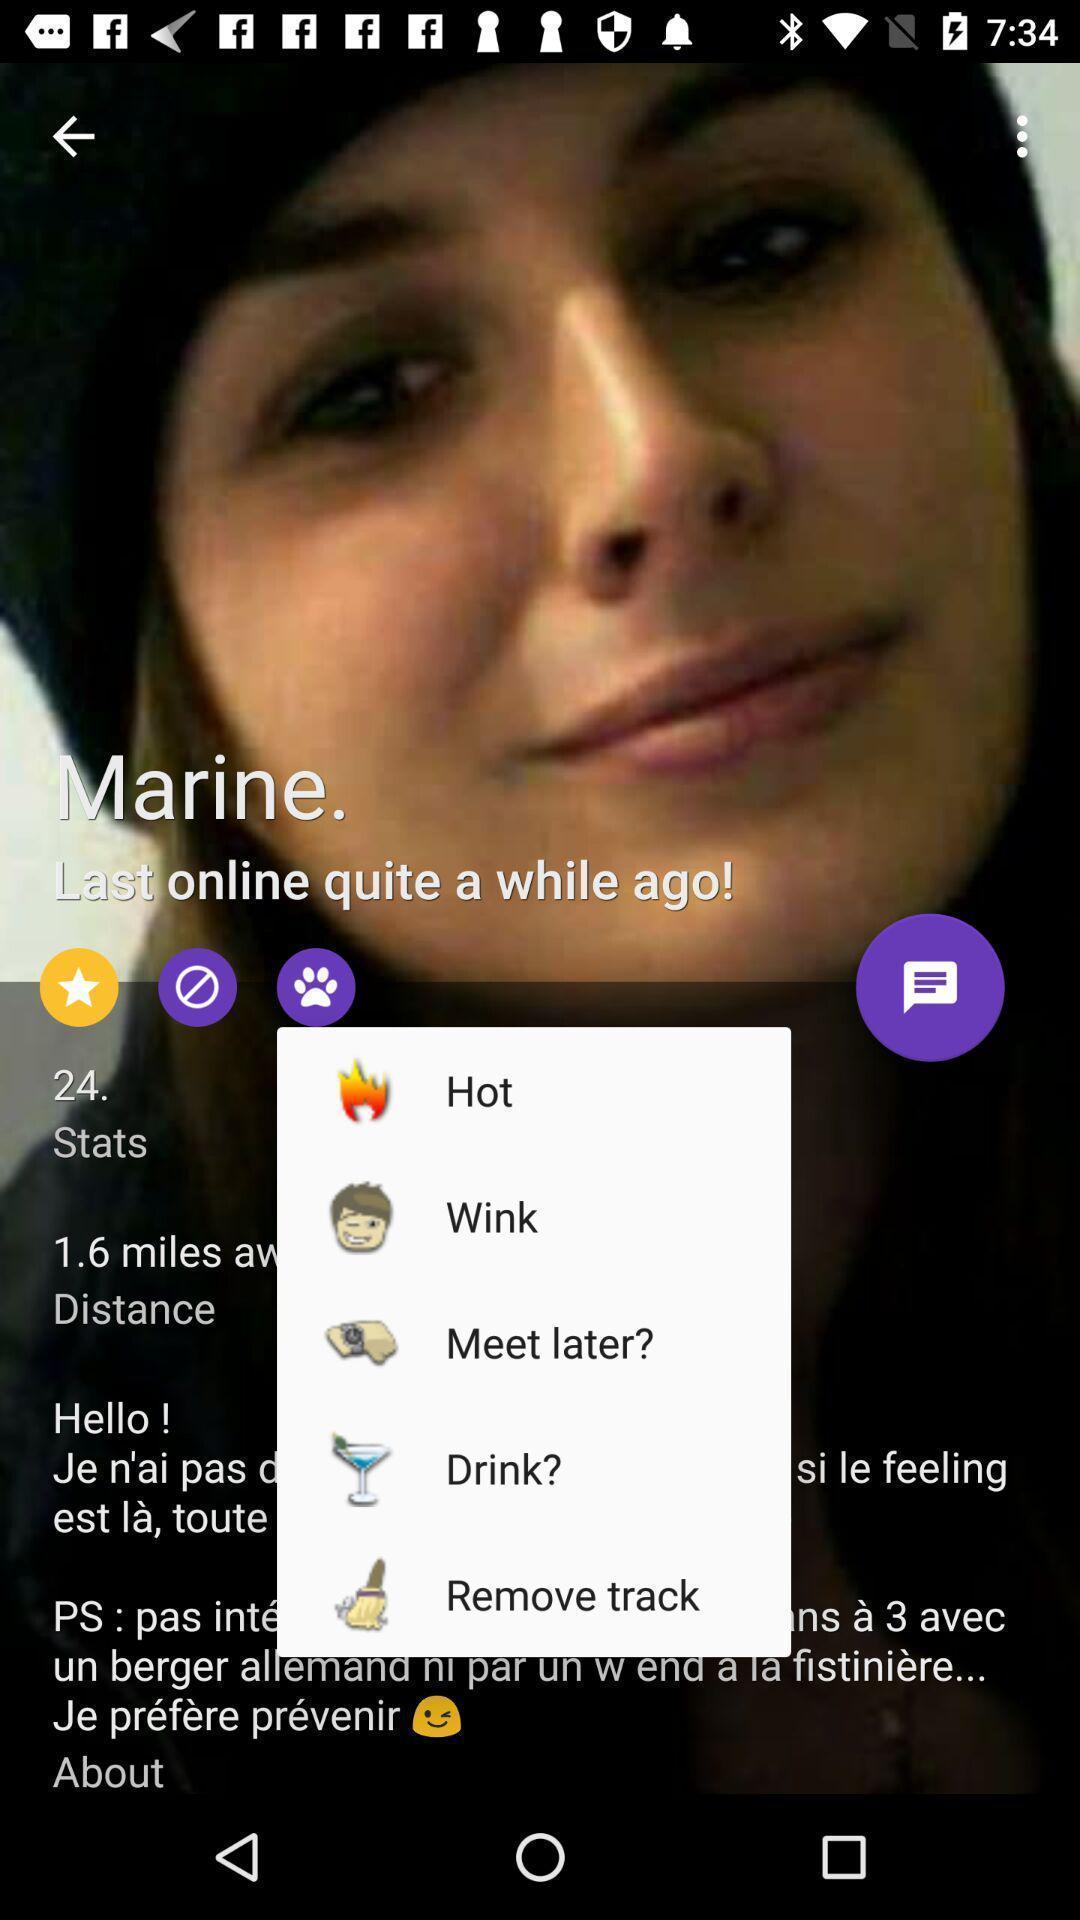What details can you identify in this image? Pop-up showing different message options. 